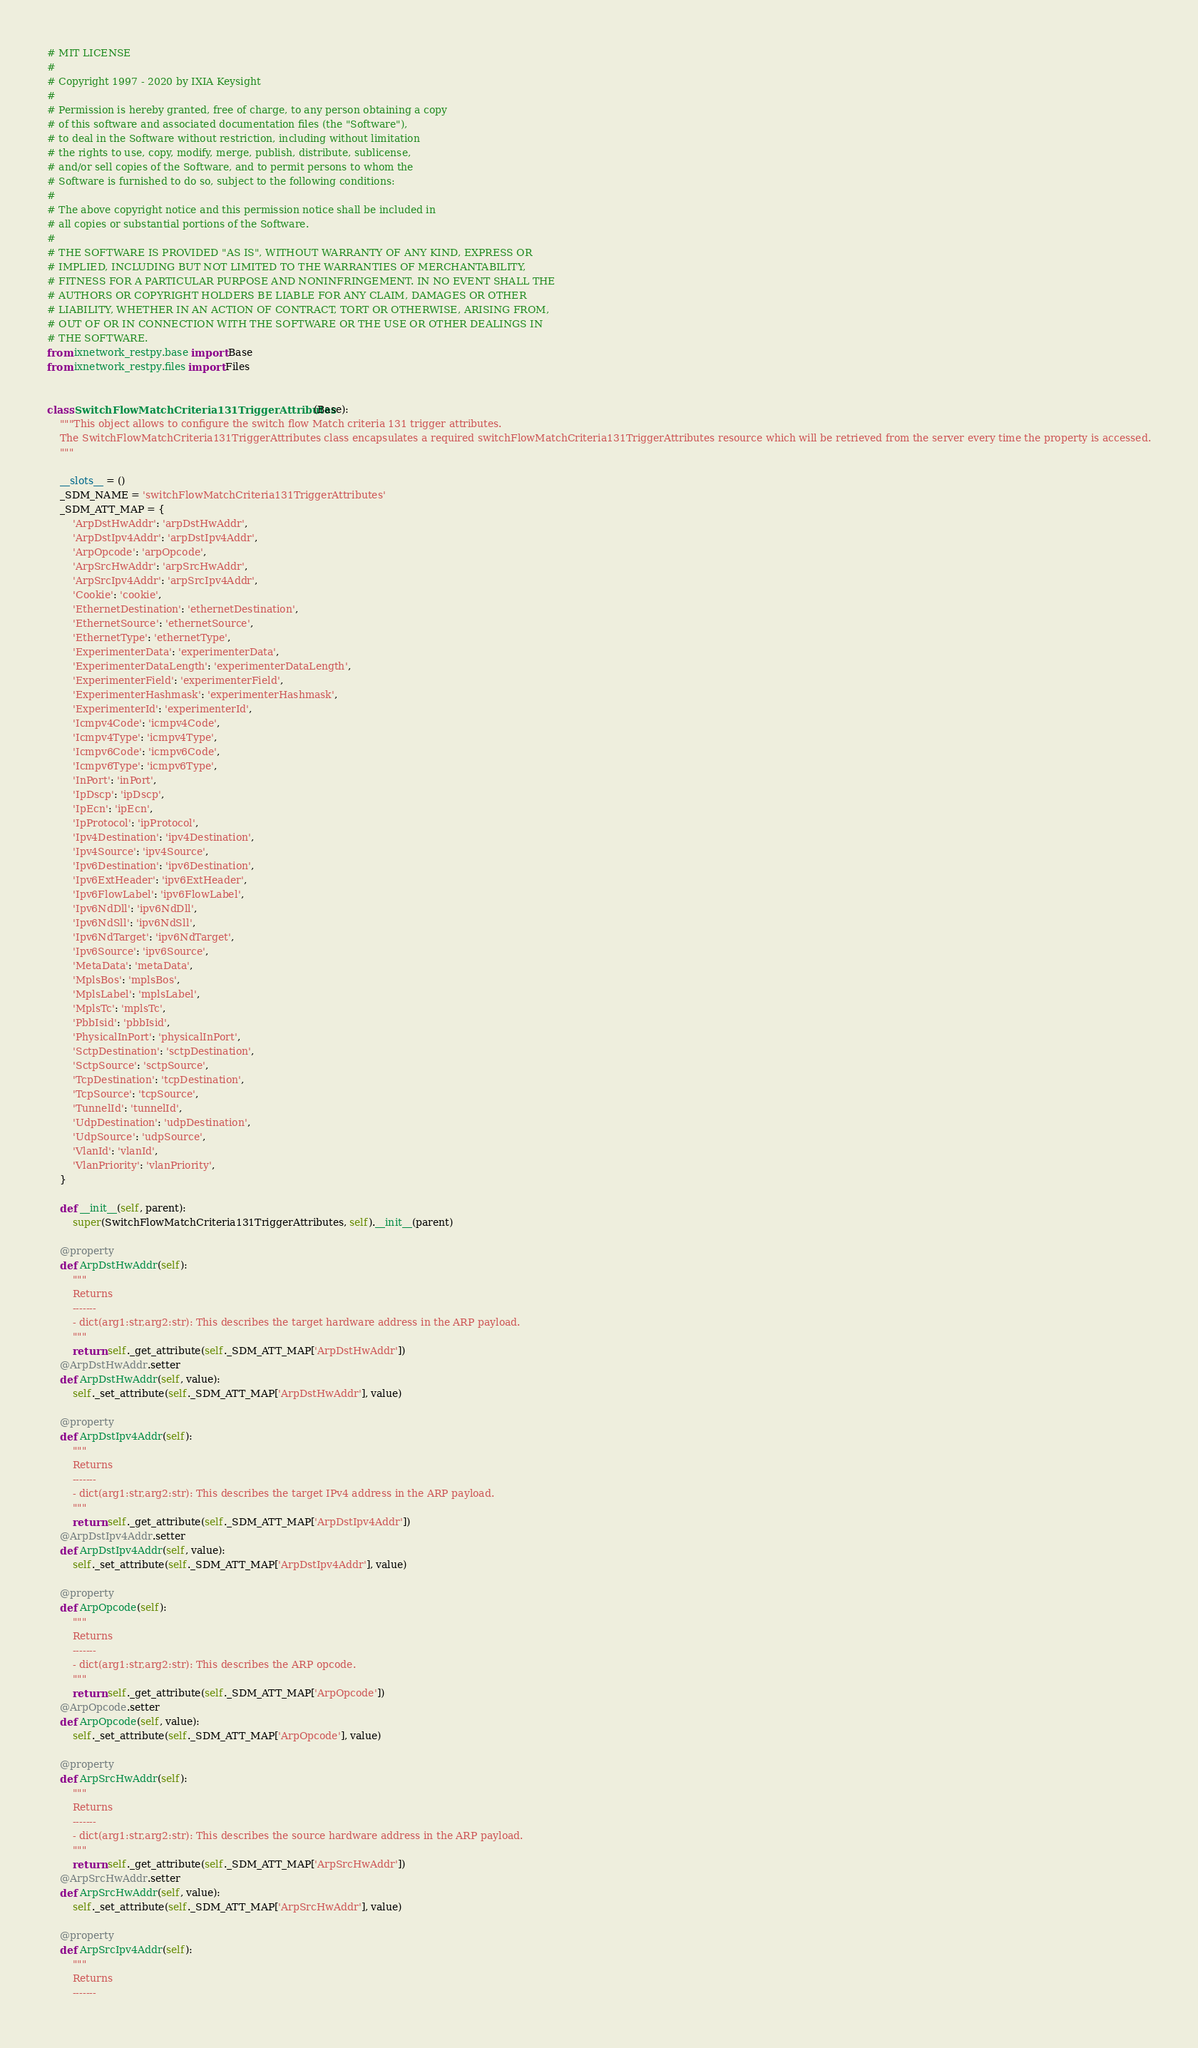Convert code to text. <code><loc_0><loc_0><loc_500><loc_500><_Python_># MIT LICENSE
#
# Copyright 1997 - 2020 by IXIA Keysight
#
# Permission is hereby granted, free of charge, to any person obtaining a copy
# of this software and associated documentation files (the "Software"),
# to deal in the Software without restriction, including without limitation
# the rights to use, copy, modify, merge, publish, distribute, sublicense,
# and/or sell copies of the Software, and to permit persons to whom the
# Software is furnished to do so, subject to the following conditions:
#
# The above copyright notice and this permission notice shall be included in
# all copies or substantial portions of the Software.
#
# THE SOFTWARE IS PROVIDED "AS IS", WITHOUT WARRANTY OF ANY KIND, EXPRESS OR
# IMPLIED, INCLUDING BUT NOT LIMITED TO THE WARRANTIES OF MERCHANTABILITY,
# FITNESS FOR A PARTICULAR PURPOSE AND NONINFRINGEMENT. IN NO EVENT SHALL THE
# AUTHORS OR COPYRIGHT HOLDERS BE LIABLE FOR ANY CLAIM, DAMAGES OR OTHER
# LIABILITY, WHETHER IN AN ACTION OF CONTRACT, TORT OR OTHERWISE, ARISING FROM,
# OUT OF OR IN CONNECTION WITH THE SOFTWARE OR THE USE OR OTHER DEALINGS IN
# THE SOFTWARE. 
from ixnetwork_restpy.base import Base
from ixnetwork_restpy.files import Files


class SwitchFlowMatchCriteria131TriggerAttributes(Base):
    """This object allows to configure the switch flow Match criteria 131 trigger attributes.
    The SwitchFlowMatchCriteria131TriggerAttributes class encapsulates a required switchFlowMatchCriteria131TriggerAttributes resource which will be retrieved from the server every time the property is accessed.
    """

    __slots__ = ()
    _SDM_NAME = 'switchFlowMatchCriteria131TriggerAttributes'
    _SDM_ATT_MAP = {
        'ArpDstHwAddr': 'arpDstHwAddr',
        'ArpDstIpv4Addr': 'arpDstIpv4Addr',
        'ArpOpcode': 'arpOpcode',
        'ArpSrcHwAddr': 'arpSrcHwAddr',
        'ArpSrcIpv4Addr': 'arpSrcIpv4Addr',
        'Cookie': 'cookie',
        'EthernetDestination': 'ethernetDestination',
        'EthernetSource': 'ethernetSource',
        'EthernetType': 'ethernetType',
        'ExperimenterData': 'experimenterData',
        'ExperimenterDataLength': 'experimenterDataLength',
        'ExperimenterField': 'experimenterField',
        'ExperimenterHashmask': 'experimenterHashmask',
        'ExperimenterId': 'experimenterId',
        'Icmpv4Code': 'icmpv4Code',
        'Icmpv4Type': 'icmpv4Type',
        'Icmpv6Code': 'icmpv6Code',
        'Icmpv6Type': 'icmpv6Type',
        'InPort': 'inPort',
        'IpDscp': 'ipDscp',
        'IpEcn': 'ipEcn',
        'IpProtocol': 'ipProtocol',
        'Ipv4Destination': 'ipv4Destination',
        'Ipv4Source': 'ipv4Source',
        'Ipv6Destination': 'ipv6Destination',
        'Ipv6ExtHeader': 'ipv6ExtHeader',
        'Ipv6FlowLabel': 'ipv6FlowLabel',
        'Ipv6NdDll': 'ipv6NdDll',
        'Ipv6NdSll': 'ipv6NdSll',
        'Ipv6NdTarget': 'ipv6NdTarget',
        'Ipv6Source': 'ipv6Source',
        'MetaData': 'metaData',
        'MplsBos': 'mplsBos',
        'MplsLabel': 'mplsLabel',
        'MplsTc': 'mplsTc',
        'PbbIsid': 'pbbIsid',
        'PhysicalInPort': 'physicalInPort',
        'SctpDestination': 'sctpDestination',
        'SctpSource': 'sctpSource',
        'TcpDestination': 'tcpDestination',
        'TcpSource': 'tcpSource',
        'TunnelId': 'tunnelId',
        'UdpDestination': 'udpDestination',
        'UdpSource': 'udpSource',
        'VlanId': 'vlanId',
        'VlanPriority': 'vlanPriority',
    }

    def __init__(self, parent):
        super(SwitchFlowMatchCriteria131TriggerAttributes, self).__init__(parent)

    @property
    def ArpDstHwAddr(self):
        """
        Returns
        -------
        - dict(arg1:str,arg2:str): This describes the target hardware address in the ARP payload.
        """
        return self._get_attribute(self._SDM_ATT_MAP['ArpDstHwAddr'])
    @ArpDstHwAddr.setter
    def ArpDstHwAddr(self, value):
        self._set_attribute(self._SDM_ATT_MAP['ArpDstHwAddr'], value)

    @property
    def ArpDstIpv4Addr(self):
        """
        Returns
        -------
        - dict(arg1:str,arg2:str): This describes the target IPv4 address in the ARP payload.
        """
        return self._get_attribute(self._SDM_ATT_MAP['ArpDstIpv4Addr'])
    @ArpDstIpv4Addr.setter
    def ArpDstIpv4Addr(self, value):
        self._set_attribute(self._SDM_ATT_MAP['ArpDstIpv4Addr'], value)

    @property
    def ArpOpcode(self):
        """
        Returns
        -------
        - dict(arg1:str,arg2:str): This describes the ARP opcode.
        """
        return self._get_attribute(self._SDM_ATT_MAP['ArpOpcode'])
    @ArpOpcode.setter
    def ArpOpcode(self, value):
        self._set_attribute(self._SDM_ATT_MAP['ArpOpcode'], value)

    @property
    def ArpSrcHwAddr(self):
        """
        Returns
        -------
        - dict(arg1:str,arg2:str): This describes the source hardware address in the ARP payload.
        """
        return self._get_attribute(self._SDM_ATT_MAP['ArpSrcHwAddr'])
    @ArpSrcHwAddr.setter
    def ArpSrcHwAddr(self, value):
        self._set_attribute(self._SDM_ATT_MAP['ArpSrcHwAddr'], value)

    @property
    def ArpSrcIpv4Addr(self):
        """
        Returns
        -------</code> 